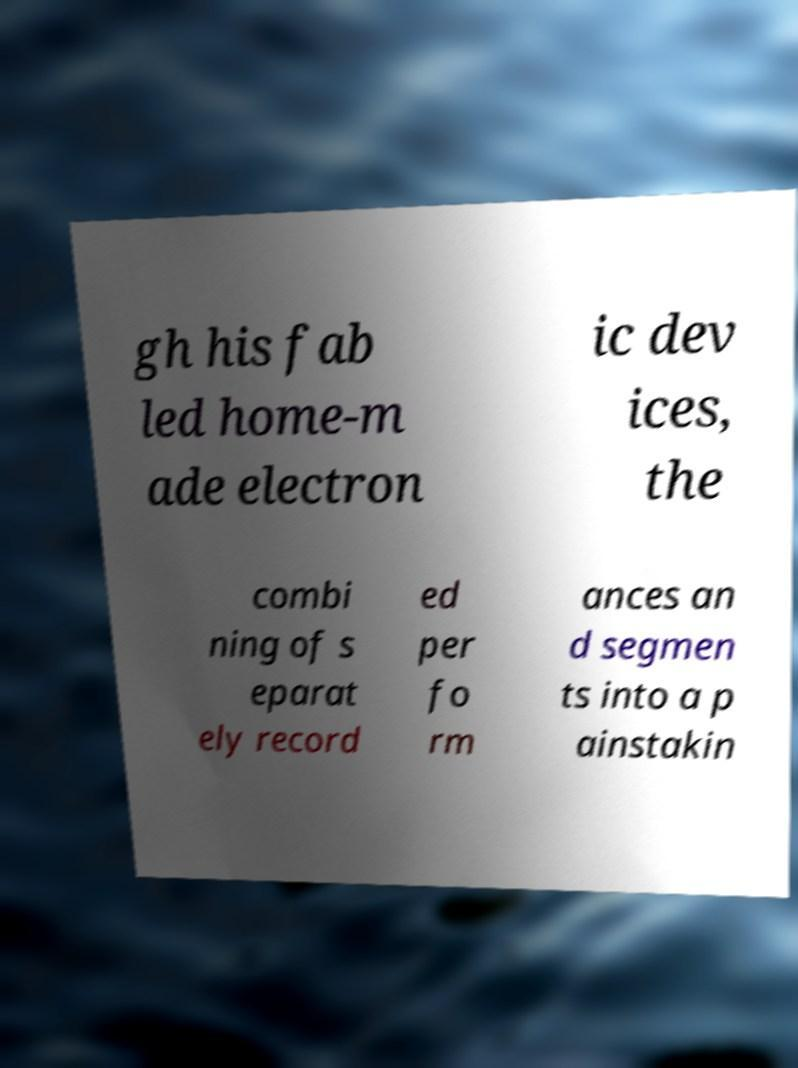Please read and relay the text visible in this image. What does it say? gh his fab led home-m ade electron ic dev ices, the combi ning of s eparat ely record ed per fo rm ances an d segmen ts into a p ainstakin 